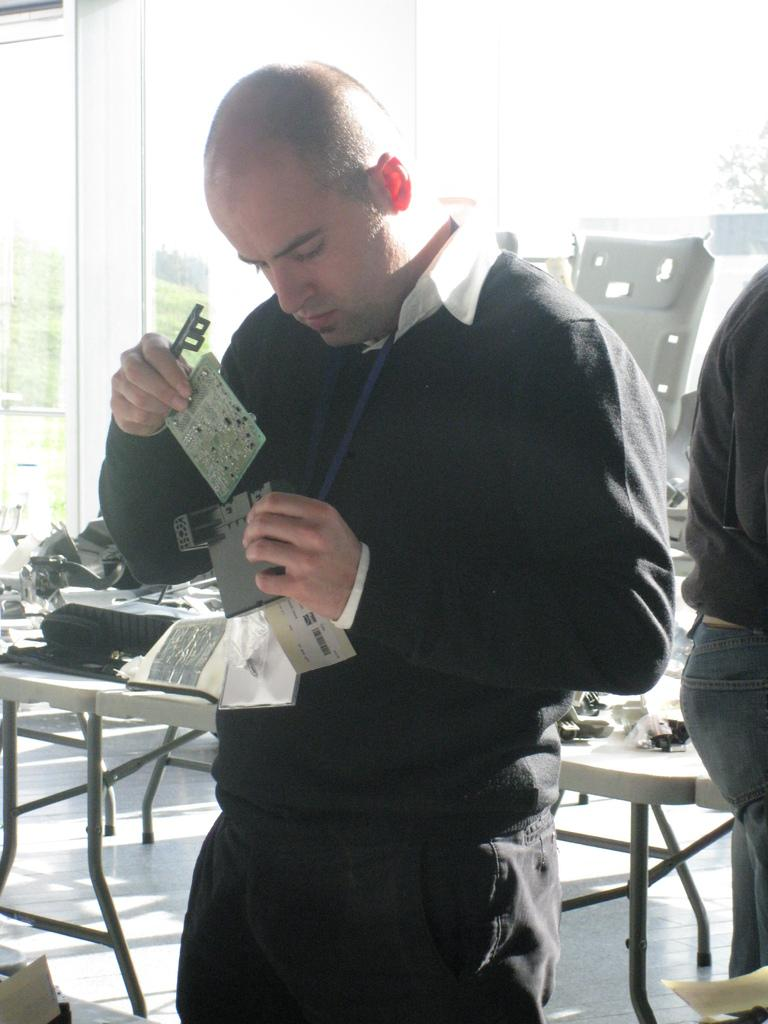Who is present in the image? There is a man in the image. What is the man doing in the image? The man is standing in the image. What is the man holding in his hand? The man is holding papers in his hand. What type of pets can be seen in the image? There are no pets present in the image. What is the man using to stretch in the image? The man is not stretching in the image, and there is no rake present. 